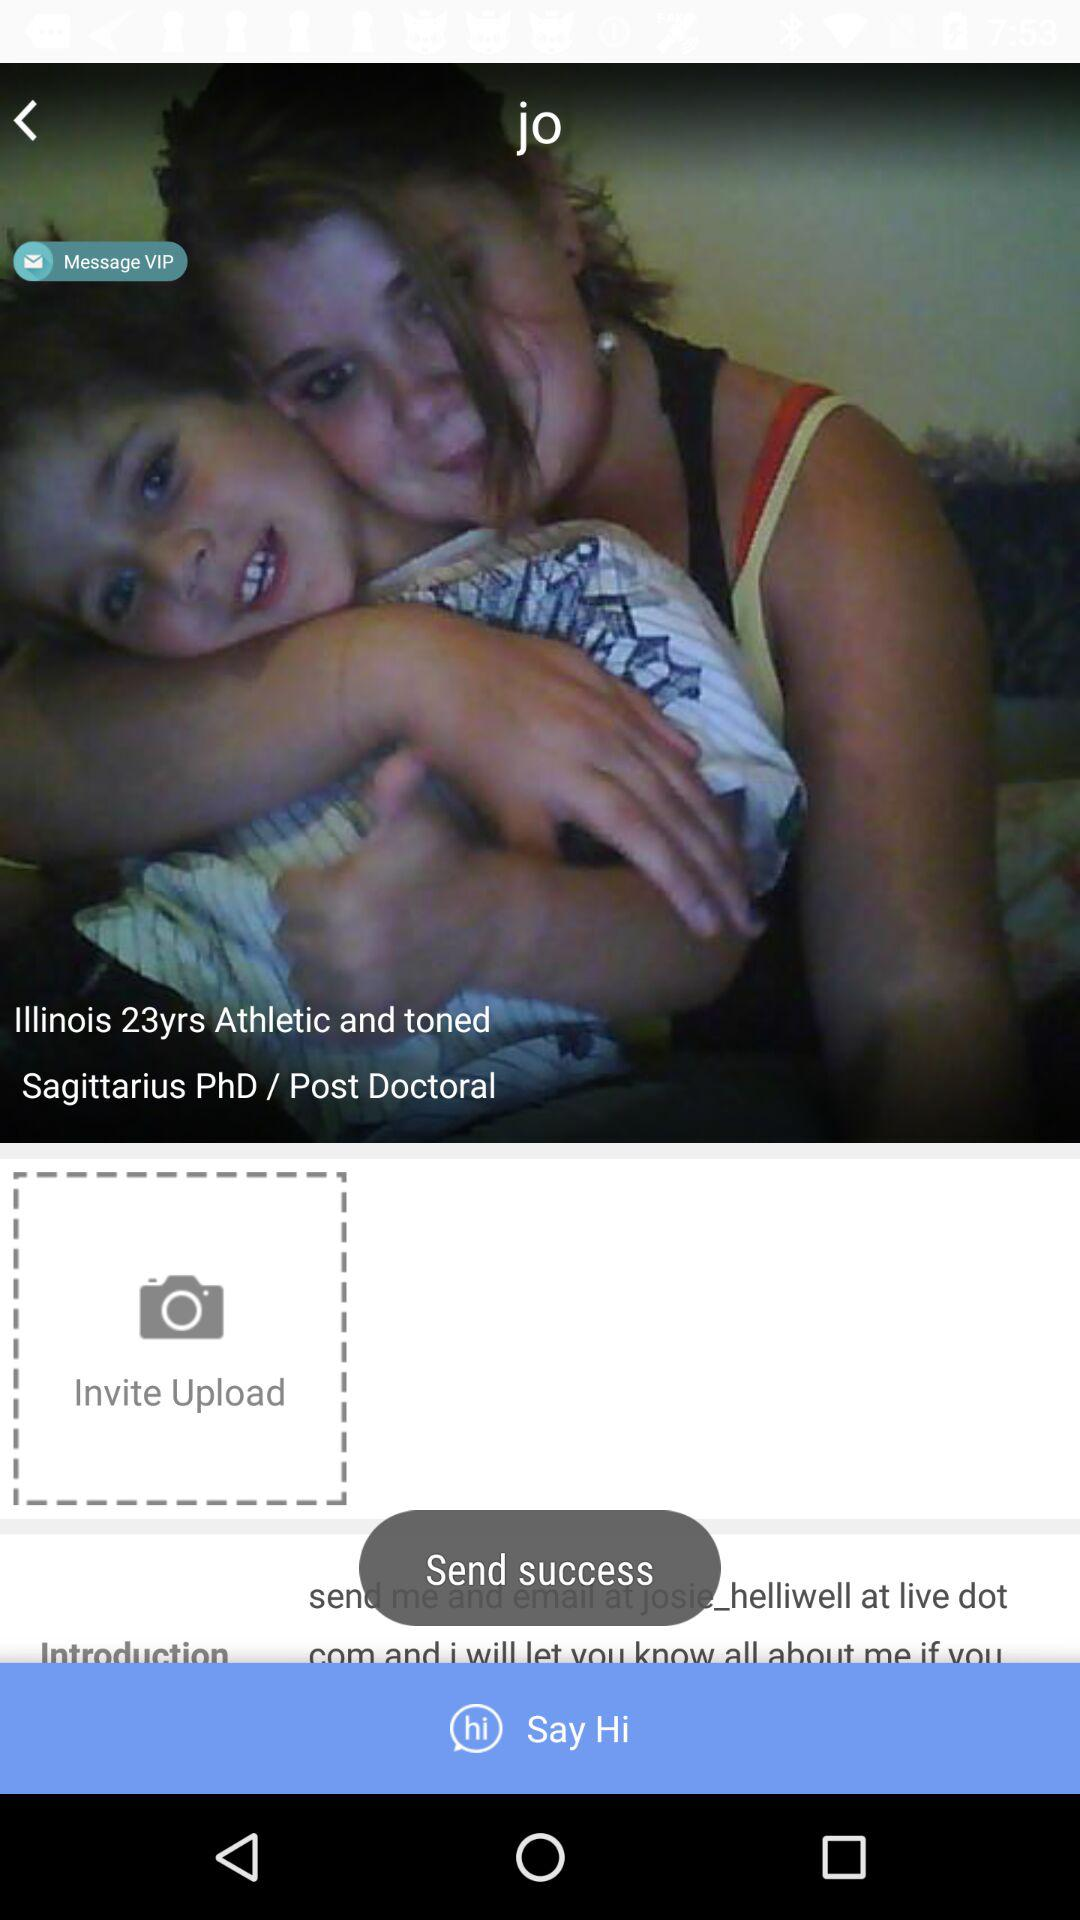What is the name? The name is Jo. 